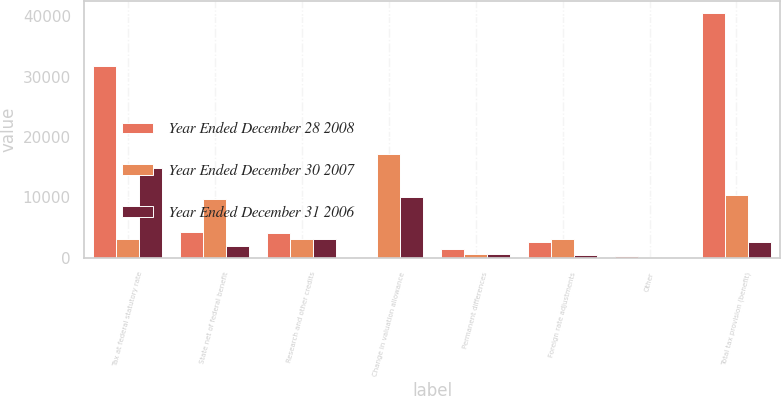Convert chart to OTSL. <chart><loc_0><loc_0><loc_500><loc_500><stacked_bar_chart><ecel><fcel>Tax at federal statutory rate<fcel>State net of federal benefit<fcel>Research and other credits<fcel>Change in valuation allowance<fcel>Permanent differences<fcel>Foreign rate adjustments<fcel>Other<fcel>Total tax provision (benefit)<nl><fcel>Year Ended December 28 2008<fcel>31817<fcel>4242<fcel>4060<fcel>149<fcel>1449<fcel>2619<fcel>241<fcel>40429<nl><fcel>Year Ended December 30 2007<fcel>3096<fcel>9672<fcel>3118<fcel>17125<fcel>653<fcel>3160<fcel>165<fcel>10426<nl><fcel>Year Ended December 31 2006<fcel>14945<fcel>1963<fcel>3096<fcel>10038<fcel>573<fcel>430<fcel>8<fcel>2652<nl></chart> 